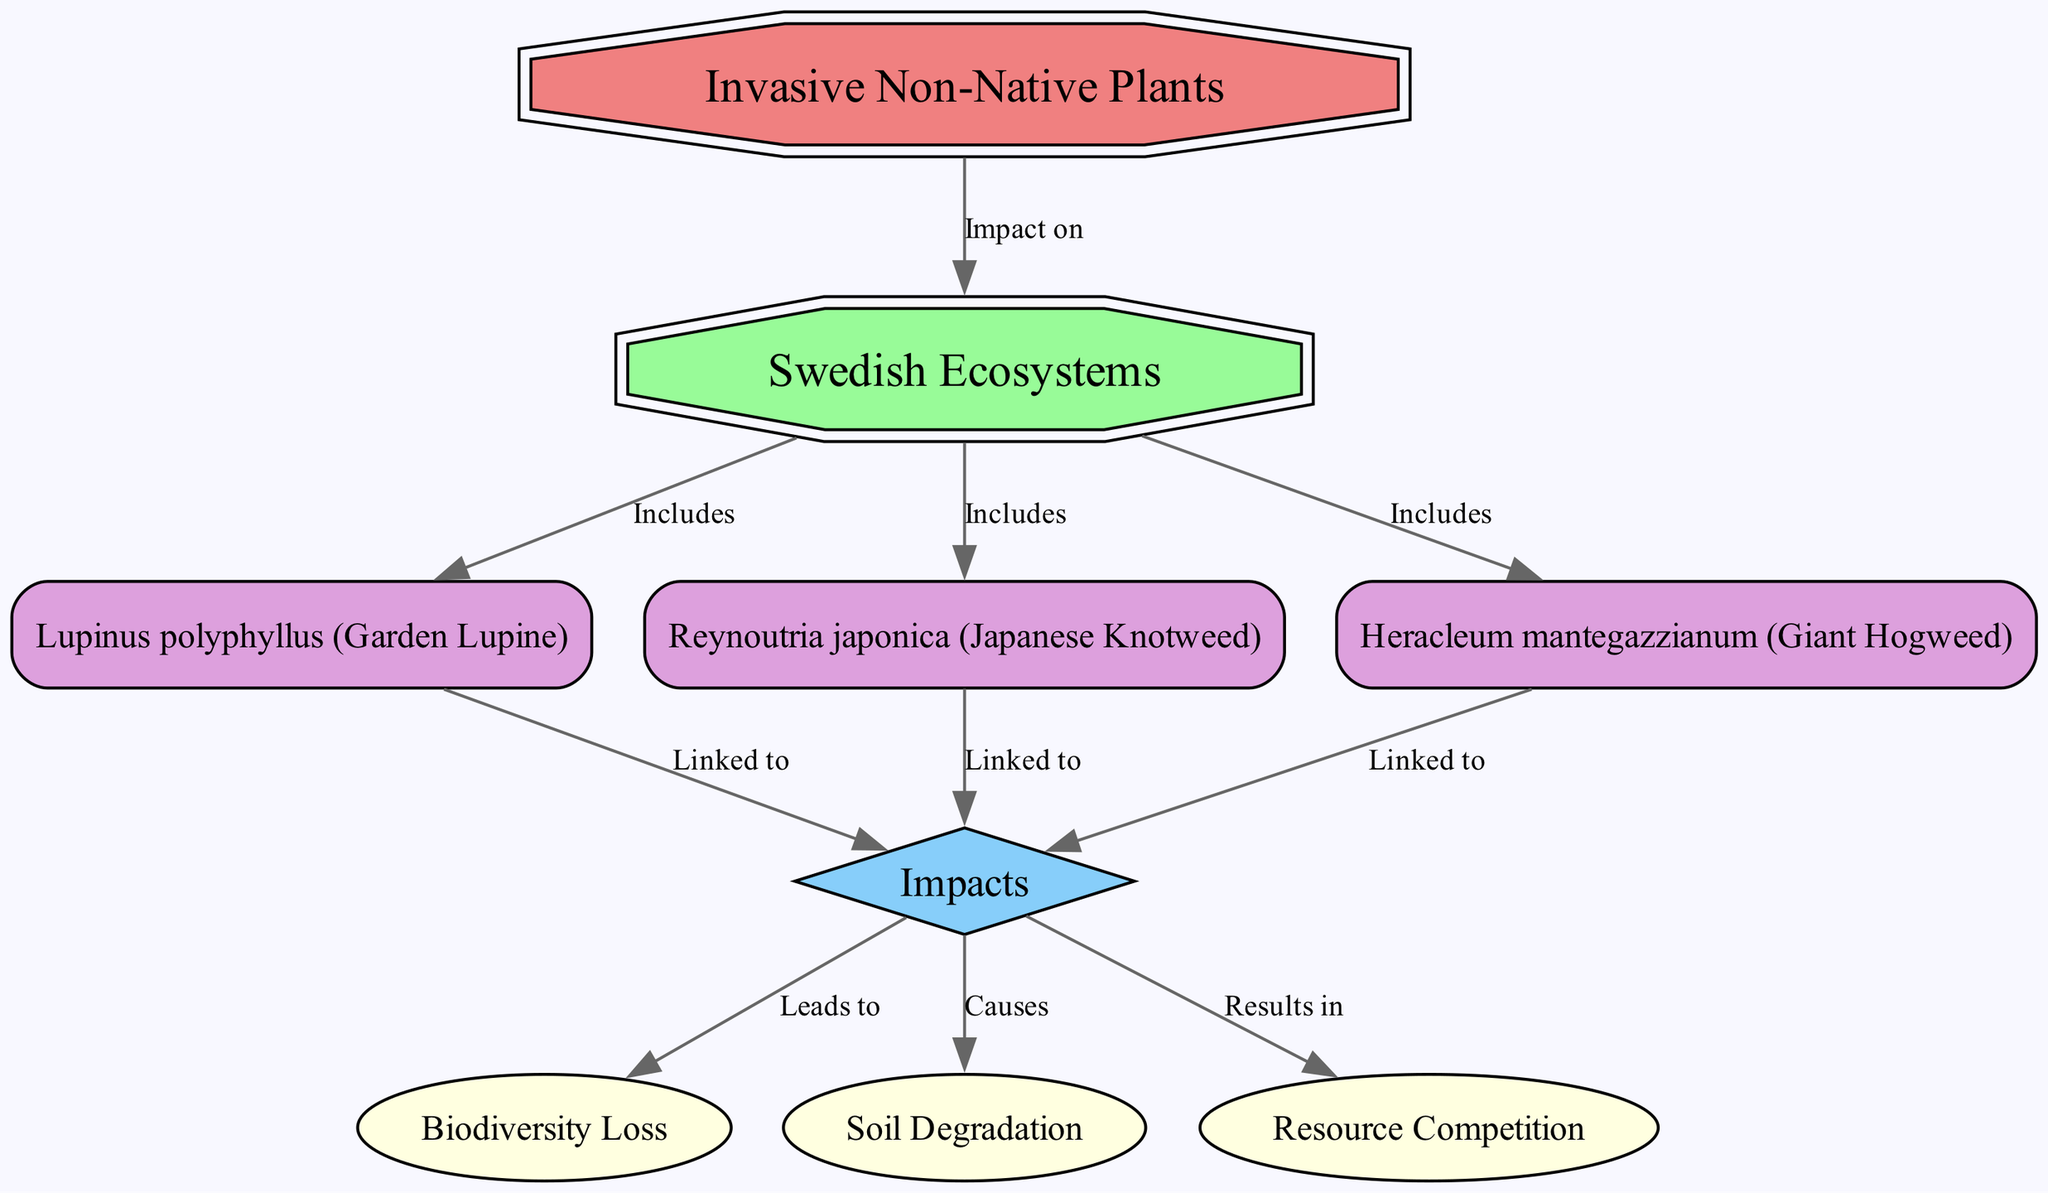What is the main subject of the diagram? The main subject is indicated by the first node, which is "Invasive Non-Native Plants." This node is positioned at the top and serves as the primary focus of the diagram.
Answer: Invasive Non-Native Plants How many invasive non-native plant species are included in the diagram? The diagram includes three species nodes: "Lupinus polyphyllus," "Reynoutria japonica," and "Heracleum mantegazzianum." By counting these nodes, we find there are three species depicted.
Answer: 3 What type of visual element represents the impacts of invasive plants? The diagram utilizes a diamond shape to represent "Impacts." This shape differentiates it from the other types of nodes, suggesting its role as a central concept connected to various outcomes.
Answer: Diamond What impact is linked to Lupinus polyphyllus? The node "Lupinus polyphyllus" is linked to "Impacts," which is indicated by the edge labeled "Linked to." This relationship shows that Lupinus has an impact on the ecosystem.
Answer: Impacts What are the three consequences listed from the impacts of invasive non-native plants? The three consequences directed from "Impacts" include "Biodiversity Loss," "Soil Degradation," and "Resource Competition." Each of these ellipses is connected to the "Impacts" node, illustrating the outcomes of invasive species.
Answer: Biodiversity Loss, Soil Degradation, Resource Competition Which non-native species is directly linked to biodiversity loss? Both "Lupinus polyphyllus" and "Reynoutria japonica" are linked to "Impacts," which leads to "Biodiversity Loss." Therefore, the species causing biodiversity loss is represented by these links.
Answer: Lupinus polyphyllus, Reynoutria japonica What is the connection type between Swedish ecosystems and invasive non-native plants? The connection is labeled "Impact on," which indicates that invasive non-native plants affect Swedish ecosystems. This is directly shown in the edge stemming from "Invasive Non-Native Plants" to "Swedish Ecosystems."
Answer: Impact on Which plant species is associated with soil degradation? "Heracleum mantegazzianum" is linked to "Impacts," which causes "Soil Degradation." This detail highlights the causal relationship between this species and soil degradation.
Answer: Heracleum mantegazzianum What is the role of the node labeled "Impacts"? The node "Impacts" serves as a central node that connects various negative outcomes (like biodiversity loss, soil degradation, and resource competition) resulting from the presence of invasive non-native plants. This can be deduced from its position and the outgoing edges.
Answer: Central node for negative outcomes 